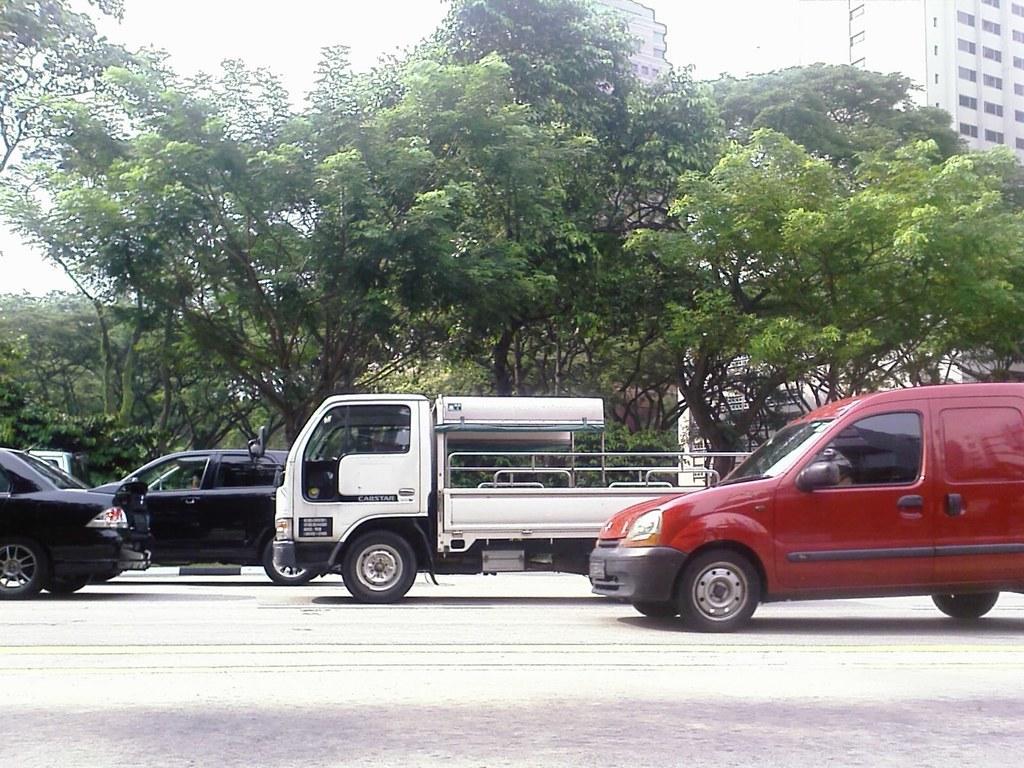Describe this image in one or two sentences. In the background we can see the buildings. It seems like a sunny day. In this picture we can see the trees and vehicles on the road. 